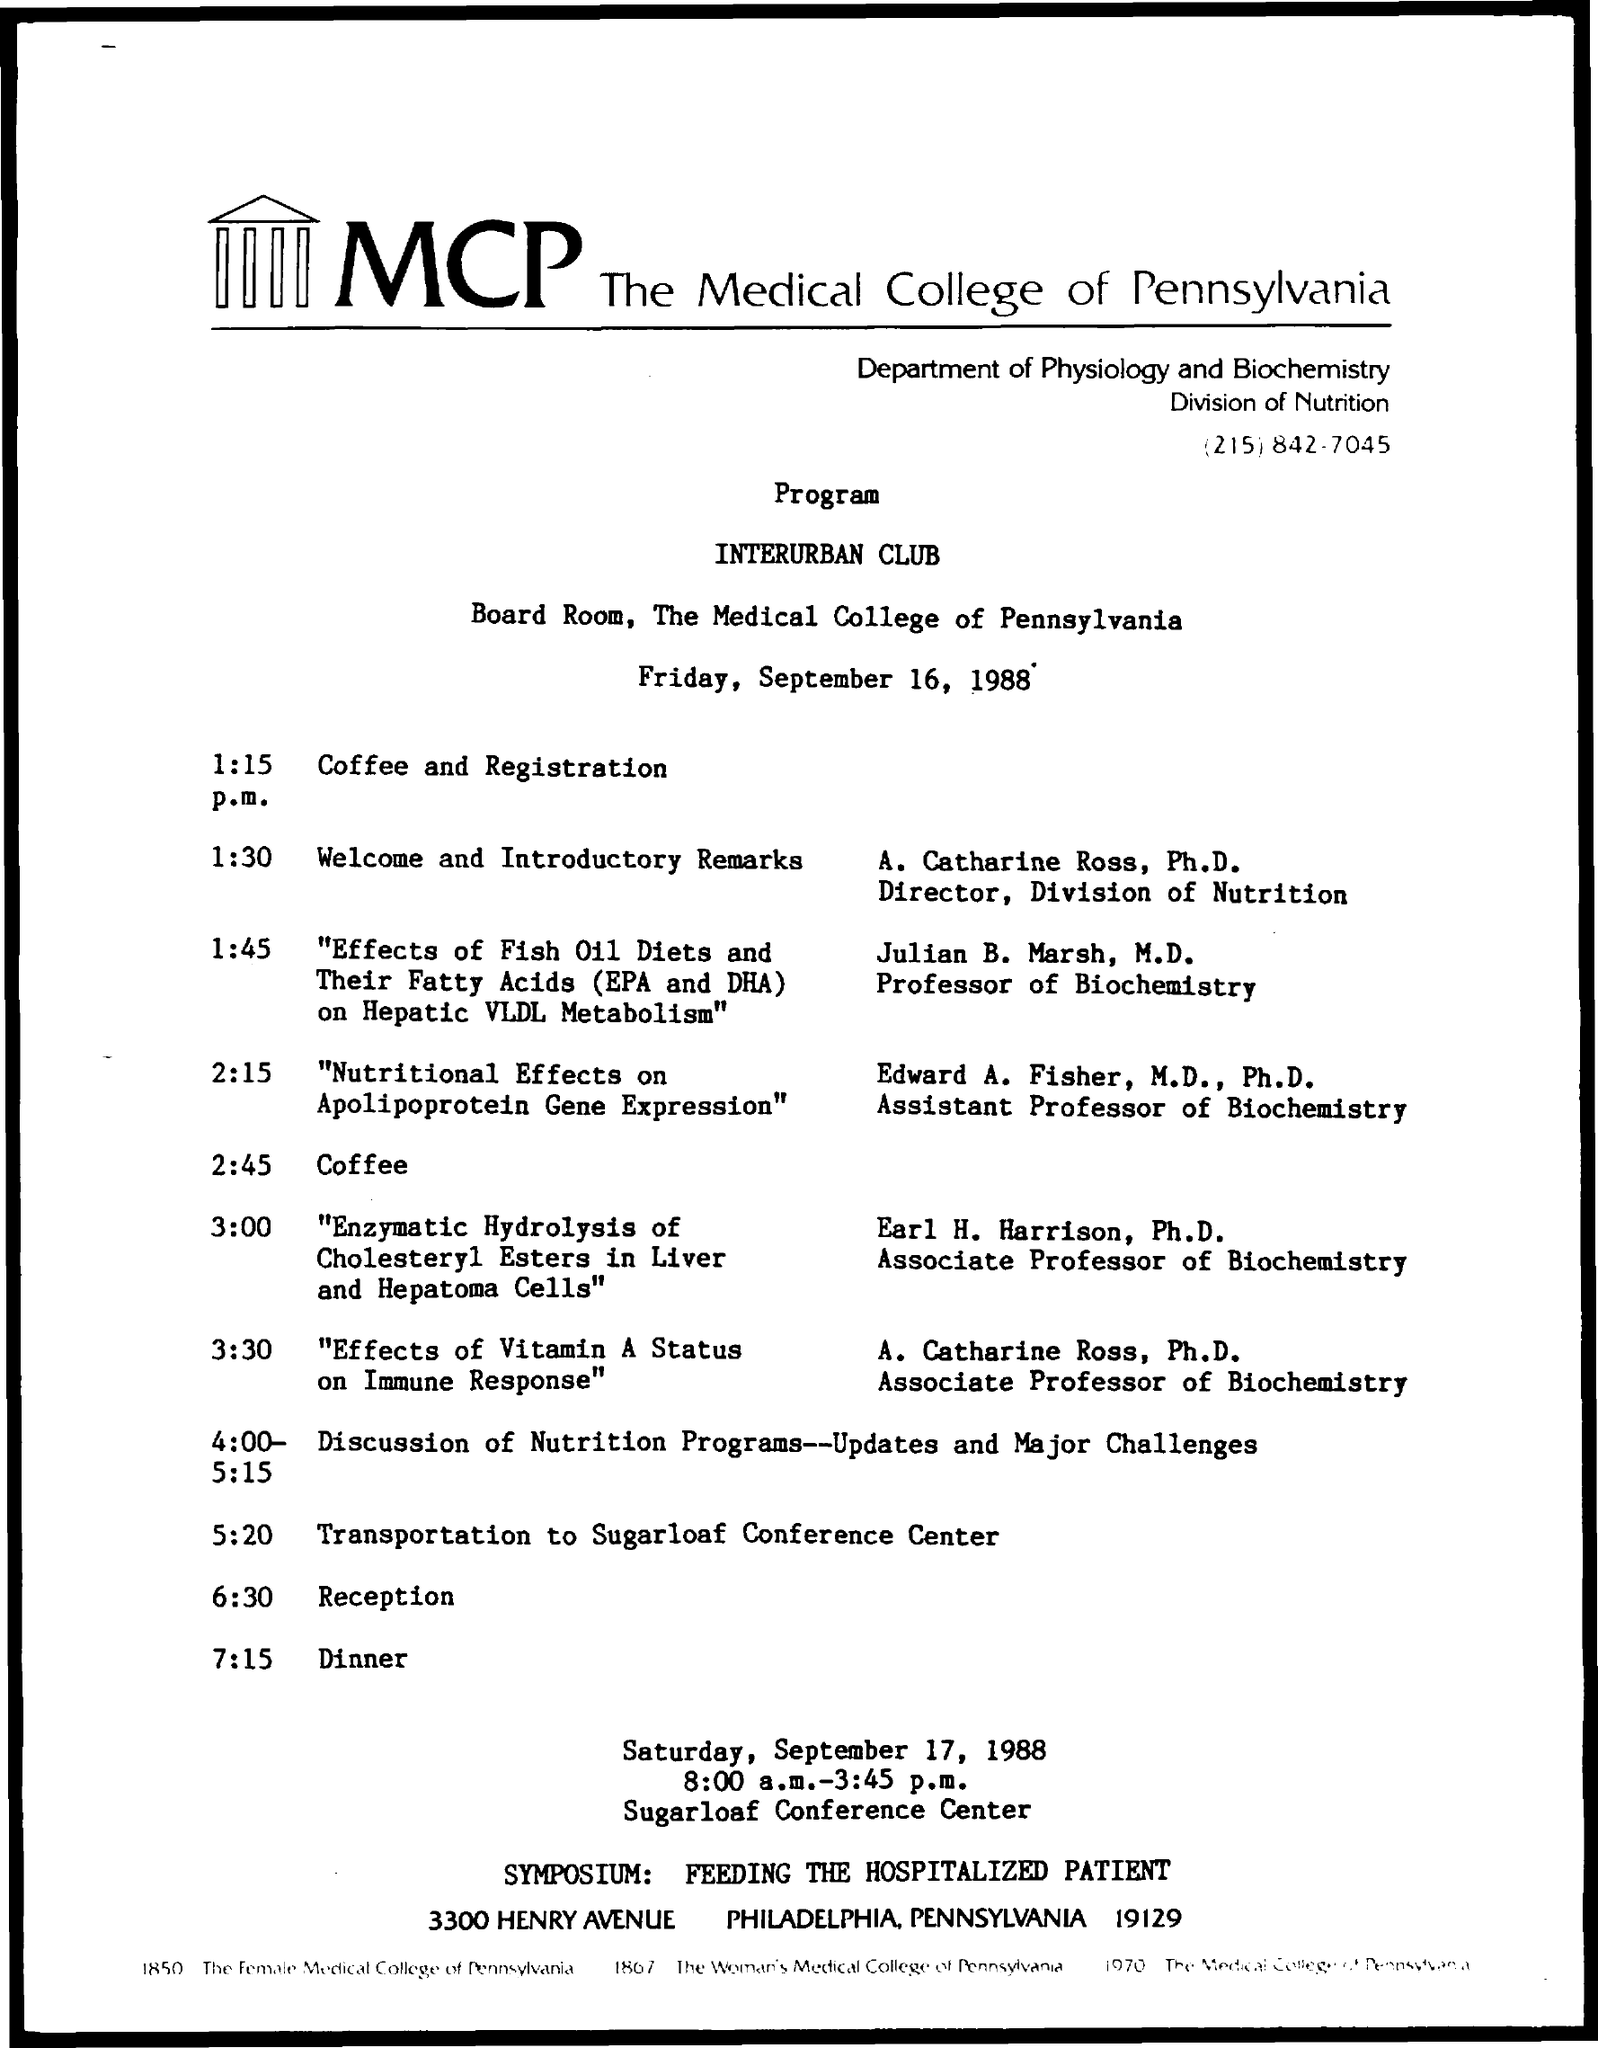What is the date scheduled for the given program ?
Your answer should be compact. Friday, september 16, 1988. What is the department mentioned in the given page ?
Provide a short and direct response. Department of physiology and biochemistry. What is the division mentioned in the given page ?
Make the answer very short. Division of nutrition. What is the schedule at the time of 1:15 p.m. ?
Provide a short and direct response. Coffee and registration. What is the schedule at the time of 1:30 p.m. ?
Offer a very short reply. Welcome and introductory remarks. What is the schedule at the time of 2:45 p.m.?
Provide a short and direct response. Coffee. What is the schedule at the time of 7:15 p.m. ?
Your answer should be very brief. Dinner. What is the given schedule at the time of 6:30 p.m. ?
Make the answer very short. Reception. 